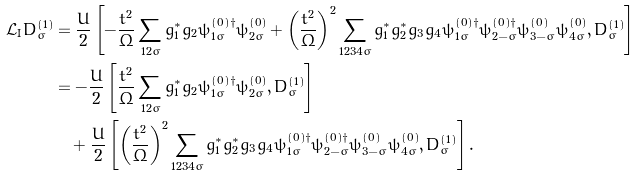<formula> <loc_0><loc_0><loc_500><loc_500>\mathcal { L _ { \text  I}}D^{(1)}_{\sigma}&=\frac{U}{2}\left[-\frac{t^{2}}{\Omega}\sum_{12\bar{\sigma}}g^{\ast}_{1}g_{2}\psi^{(0)\dag}_{1\bar{\sigma}}\psi^{(0)}_{2\bar{\sigma}}+\left(\frac{t^{2}}{\Omega}\right)^{2}\sum_{1234\bar{\sigma}}g^{\ast}_{1}g^{\ast}_{2}g_{3}g_{4}\psi^{(0)\dag}_{1\bar{\sigma}}\psi^{(0)\dag}_{2-\bar{\sigma}}\psi^{(0)}_{3-\bar{\sigma}}\psi^{(0)}_{4\bar{\sigma}},D^{(1)}_{\sigma}\right]\\ &=-\frac{U}{2}\left[\frac{t^{2}}{\Omega}\sum_{12\bar{\sigma}}g^{\ast}_{1}g_{2}\psi^{(0)\dag}_{1\bar{\sigma}}\psi^{(0)}_{2\bar{\sigma}},D^{(1)}_{\sigma}\right]\\ &\quad +\frac{U}{2}\left[\left(\frac{t^{2}}{\Omega}\right)^{2}\sum_{1234\bar{\sigma}}g^{\ast}_{1}g^{\ast}_{2}g_{3}g_{4}\psi^{(0)\dag}_{1\bar{\sigma}}\psi^{(0)\dag}_{2-\bar{\sigma}}\psi^{(0)}_{3-\bar{\sigma}}\psi^{(0)}_{4\bar{\sigma}},D^{(1)}_{\sigma}\right].</formula> 